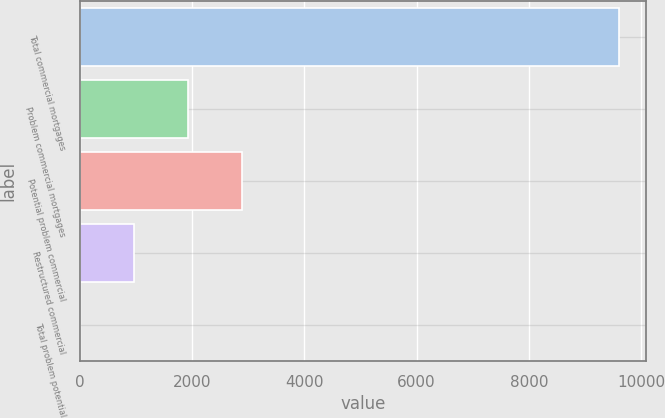Convert chart to OTSL. <chart><loc_0><loc_0><loc_500><loc_500><bar_chart><fcel>Total commercial mortgages<fcel>Problem commercial mortgages<fcel>Potential problem commercial<fcel>Restructured commercial<fcel>Total problem potential<nl><fcel>9599.6<fcel>1922.92<fcel>2882.5<fcel>963.34<fcel>3.76<nl></chart> 